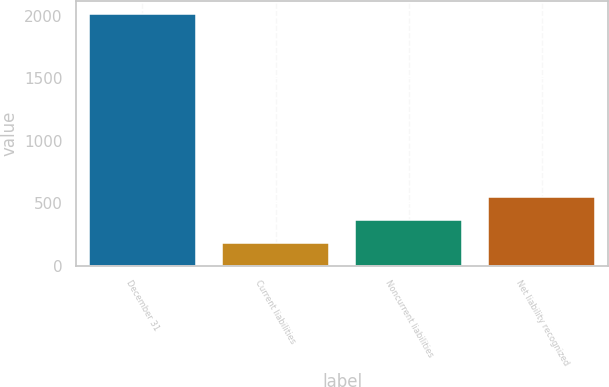Convert chart. <chart><loc_0><loc_0><loc_500><loc_500><bar_chart><fcel>December 31<fcel>Current liabilities<fcel>Noncurrent liabilities<fcel>Net liability recognized<nl><fcel>2015<fcel>179<fcel>362.6<fcel>546.2<nl></chart> 